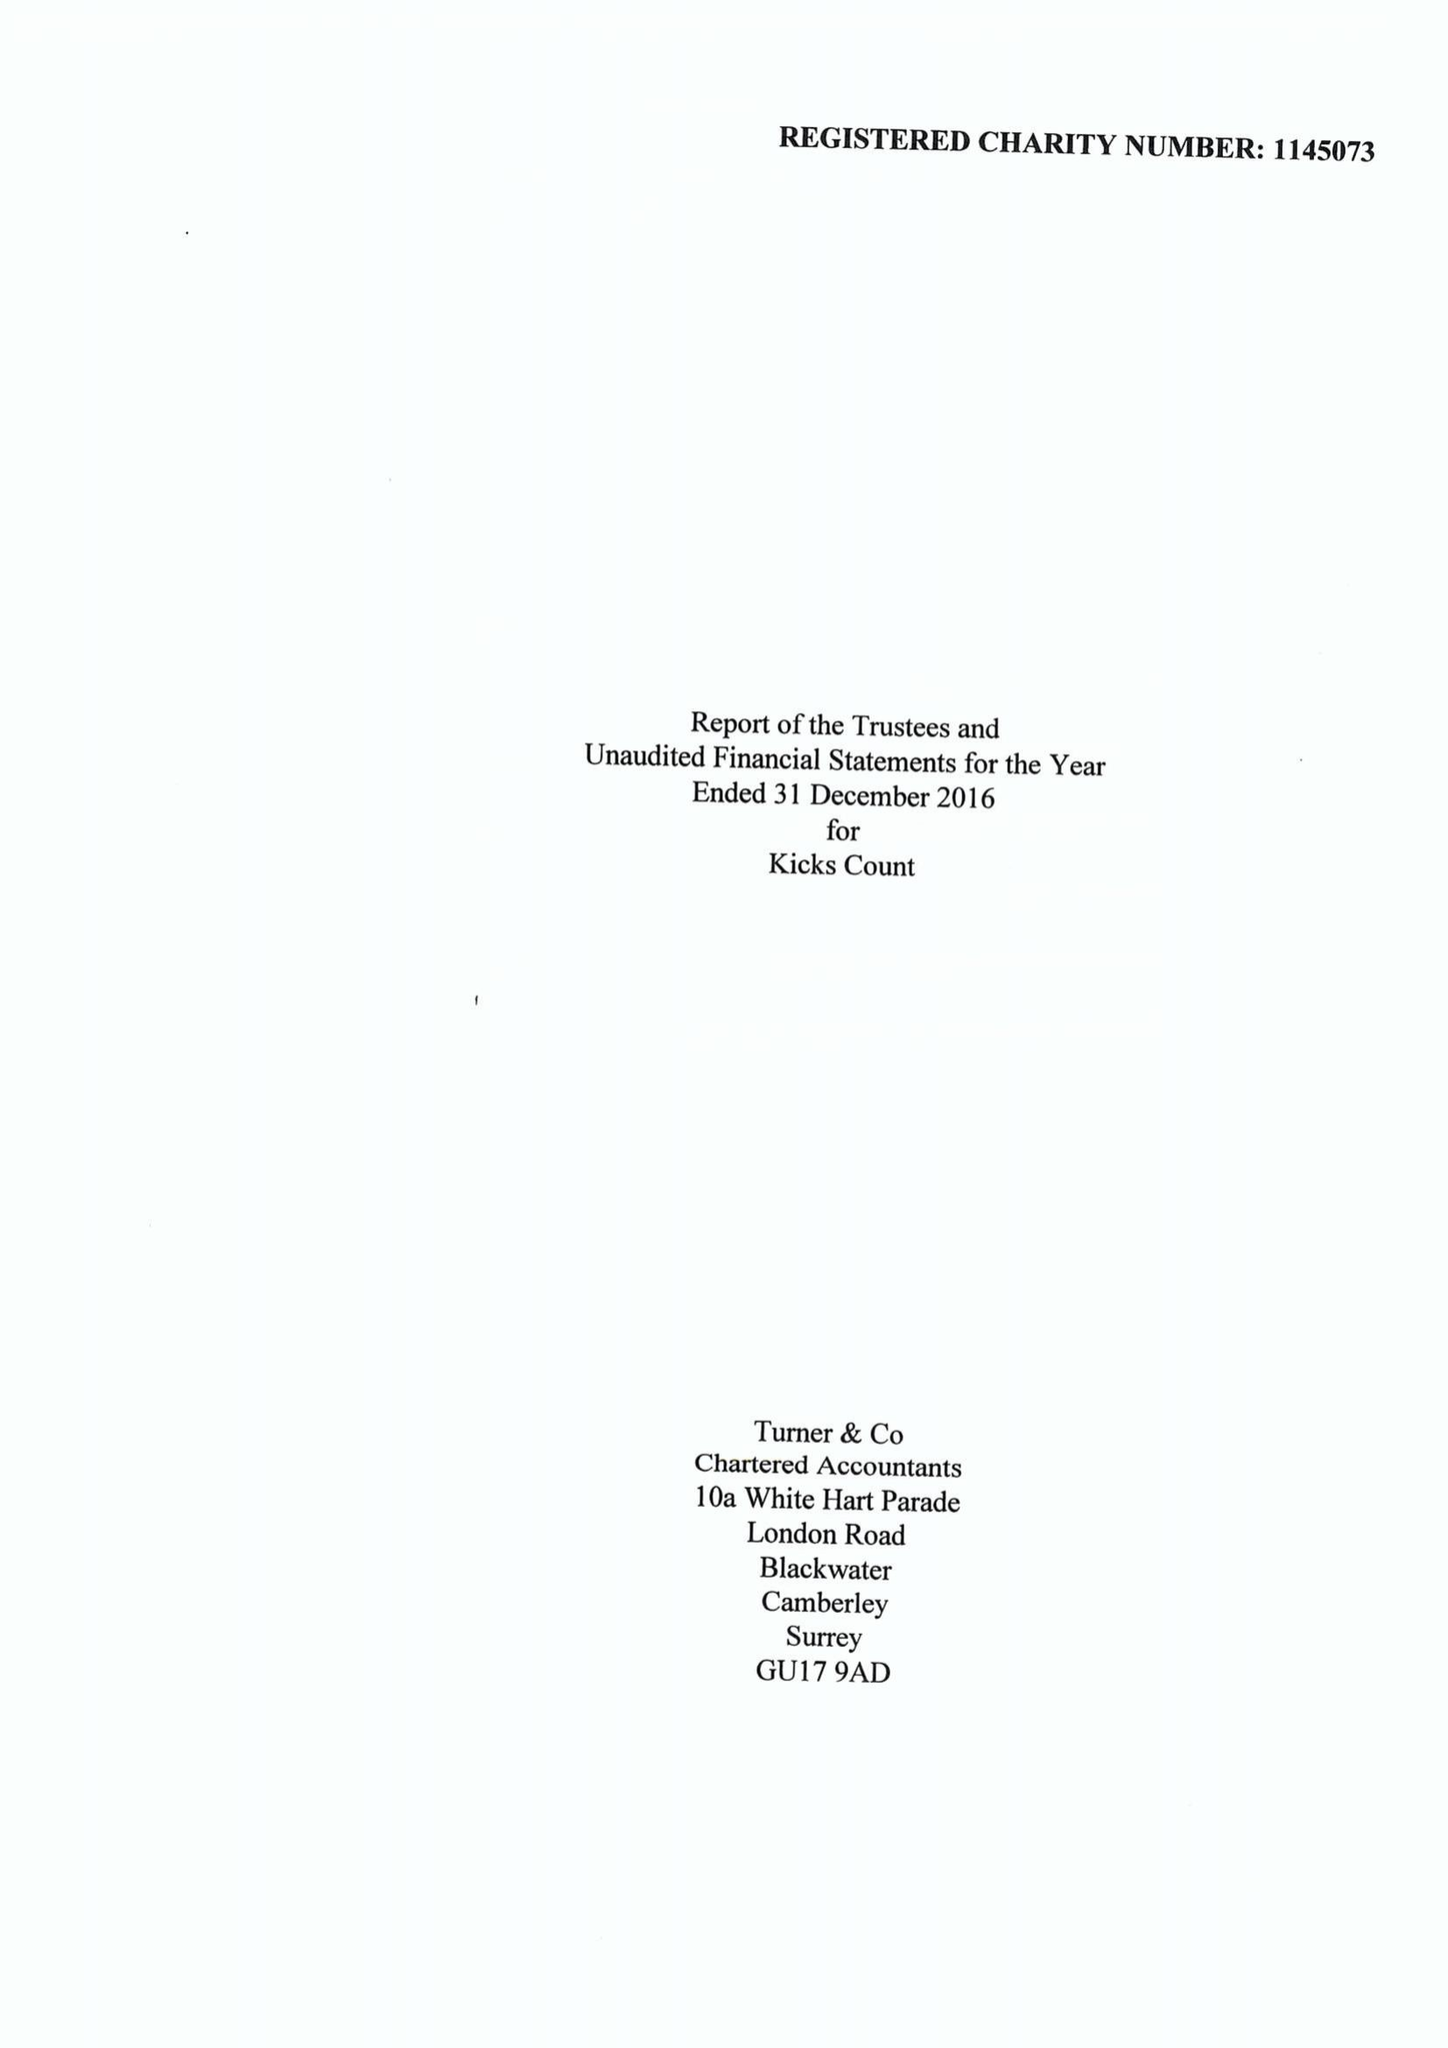What is the value for the address__post_town?
Answer the question using a single word or phrase. WOKING 